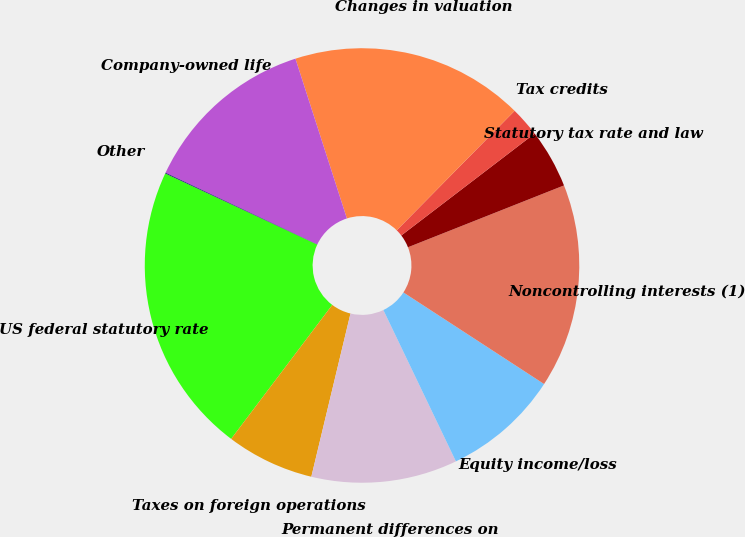Convert chart. <chart><loc_0><loc_0><loc_500><loc_500><pie_chart><fcel>US federal statutory rate<fcel>Taxes on foreign operations<fcel>Permanent differences on<fcel>Equity income/loss<fcel>Noncontrolling interests (1)<fcel>Statutory tax rate and law<fcel>Tax credits<fcel>Changes in valuation<fcel>Company-owned life<fcel>Other<nl><fcel>21.67%<fcel>6.54%<fcel>10.86%<fcel>8.7%<fcel>15.19%<fcel>4.38%<fcel>2.22%<fcel>17.35%<fcel>13.02%<fcel>0.06%<nl></chart> 